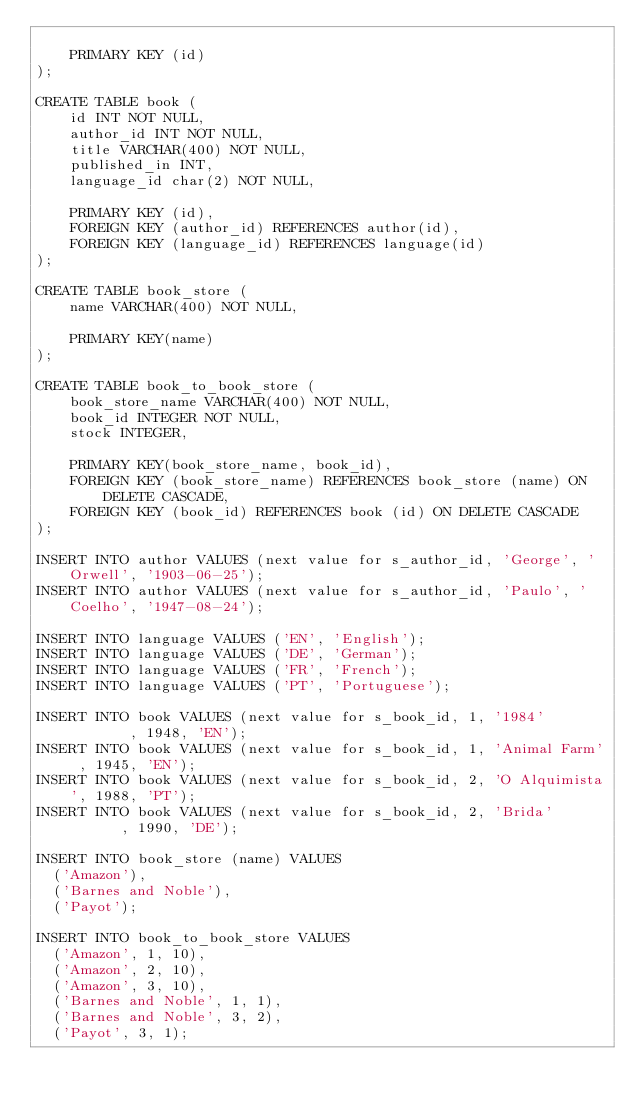<code> <loc_0><loc_0><loc_500><loc_500><_SQL_>    
    PRIMARY KEY (id)
);

CREATE TABLE book (
    id INT NOT NULL,
    author_id INT NOT NULL,
    title VARCHAR(400) NOT NULL,
    published_in INT,
    language_id char(2) NOT NULL,
    
    PRIMARY KEY (id),
    FOREIGN KEY (author_id) REFERENCES author(id),
    FOREIGN KEY (language_id) REFERENCES language(id)
);

CREATE TABLE book_store (
    name VARCHAR(400) NOT NULL,

    PRIMARY KEY(name)
);

CREATE TABLE book_to_book_store (
    book_store_name VARCHAR(400) NOT NULL,
    book_id INTEGER NOT NULL,
    stock INTEGER,

    PRIMARY KEY(book_store_name, book_id),
    FOREIGN KEY (book_store_name) REFERENCES book_store (name) ON DELETE CASCADE,
    FOREIGN KEY (book_id) REFERENCES book (id) ON DELETE CASCADE
);

INSERT INTO author VALUES (next value for s_author_id, 'George', 'Orwell', '1903-06-25');
INSERT INTO author VALUES (next value for s_author_id, 'Paulo', 'Coelho', '1947-08-24');

INSERT INTO language VALUES ('EN', 'English');
INSERT INTO language VALUES ('DE', 'German');
INSERT INTO language VALUES ('FR', 'French');
INSERT INTO language VALUES ('PT', 'Portuguese');

INSERT INTO book VALUES (next value for s_book_id, 1, '1984'        , 1948, 'EN');
INSERT INTO book VALUES (next value for s_book_id, 1, 'Animal Farm' , 1945, 'EN');
INSERT INTO book VALUES (next value for s_book_id, 2, 'O Alquimista', 1988, 'PT');
INSERT INTO book VALUES (next value for s_book_id, 2, 'Brida'       , 1990, 'DE');

INSERT INTO book_store (name) VALUES
	('Amazon'),
	('Barnes and Noble'),
	('Payot');

INSERT INTO book_to_book_store VALUES
	('Amazon', 1, 10),
	('Amazon', 2, 10),
	('Amazon', 3, 10),
	('Barnes and Noble', 1, 1),
	('Barnes and Noble', 3, 2),
	('Payot', 3, 1);
</code> 